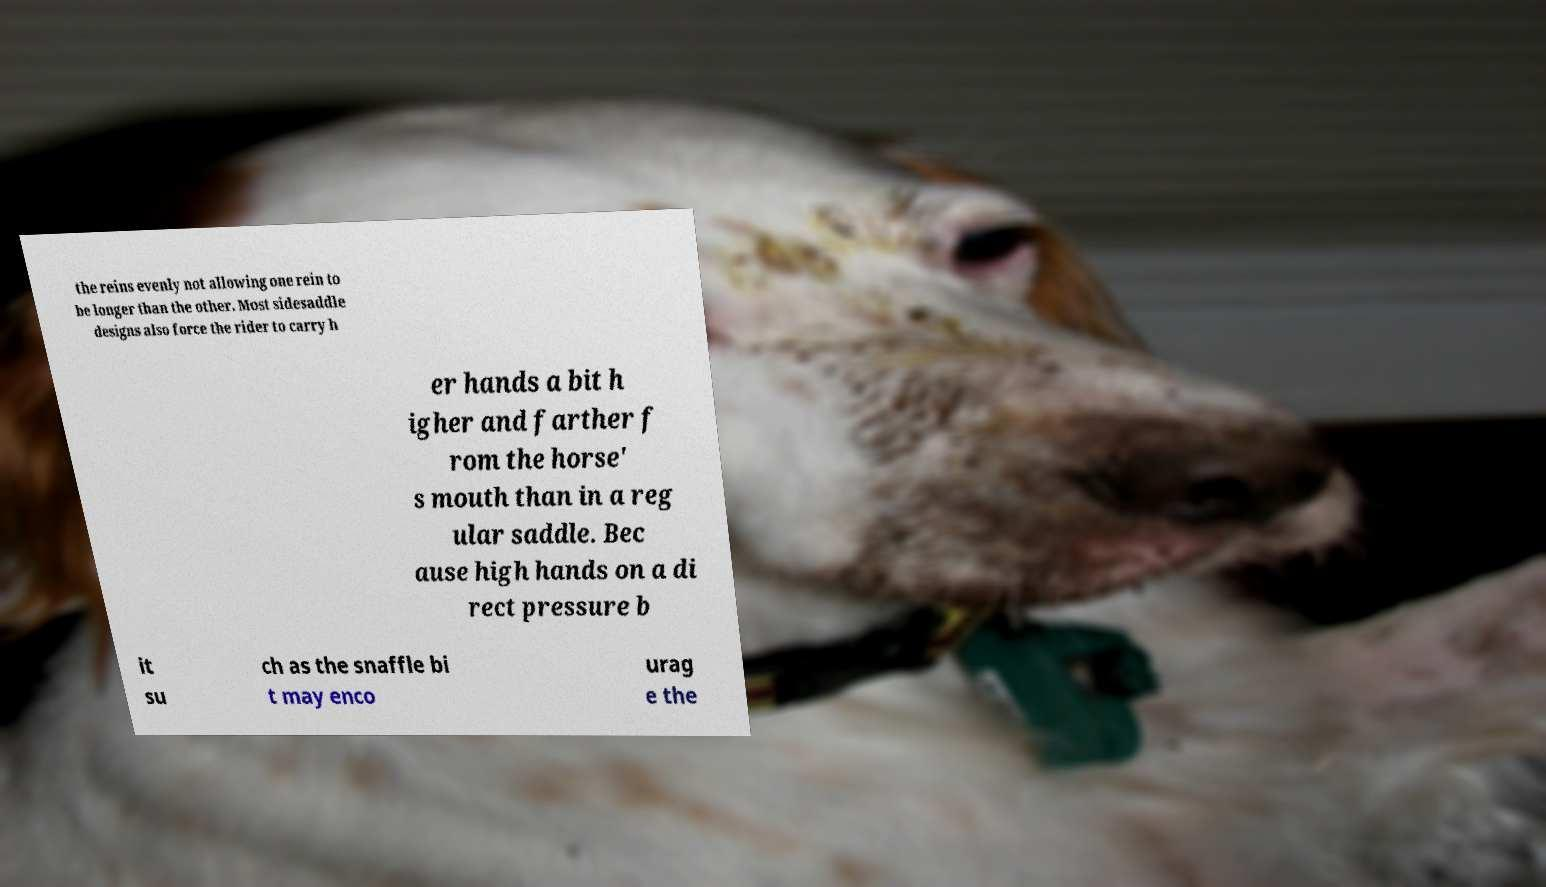Please read and relay the text visible in this image. What does it say? the reins evenly not allowing one rein to be longer than the other. Most sidesaddle designs also force the rider to carry h er hands a bit h igher and farther f rom the horse' s mouth than in a reg ular saddle. Bec ause high hands on a di rect pressure b it su ch as the snaffle bi t may enco urag e the 